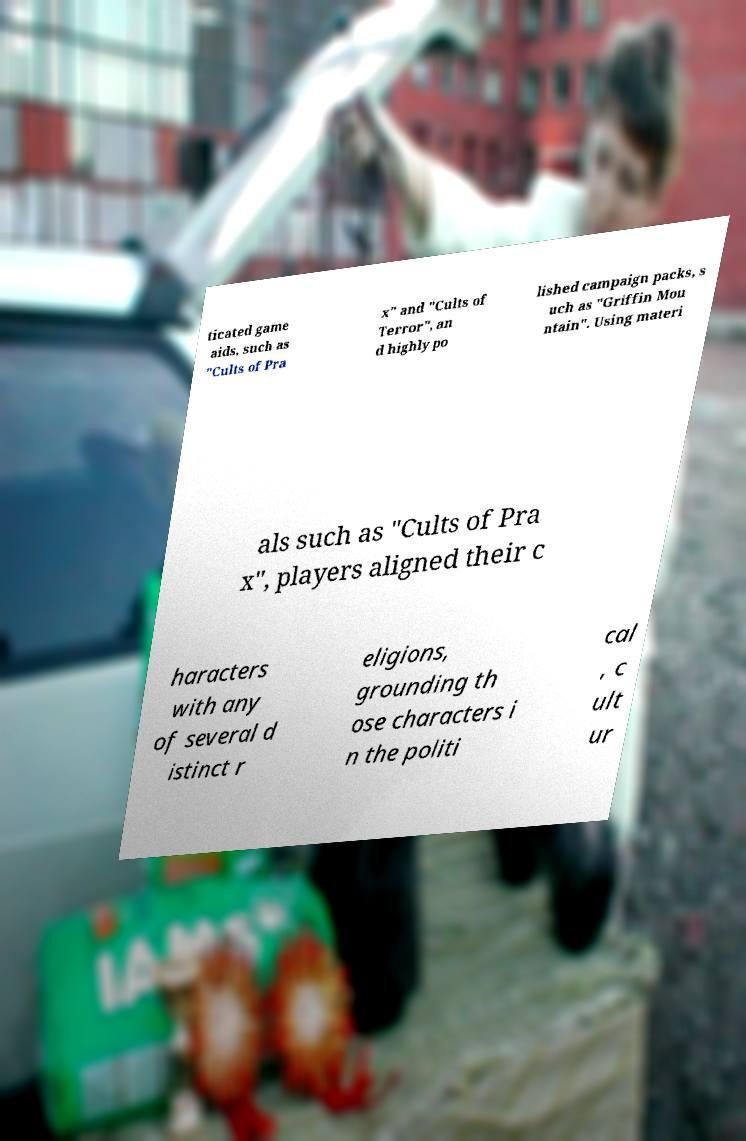Could you assist in decoding the text presented in this image and type it out clearly? ticated game aids, such as "Cults of Pra x" and "Cults of Terror", an d highly po lished campaign packs, s uch as "Griffin Mou ntain". Using materi als such as "Cults of Pra x", players aligned their c haracters with any of several d istinct r eligions, grounding th ose characters i n the politi cal , c ult ur 